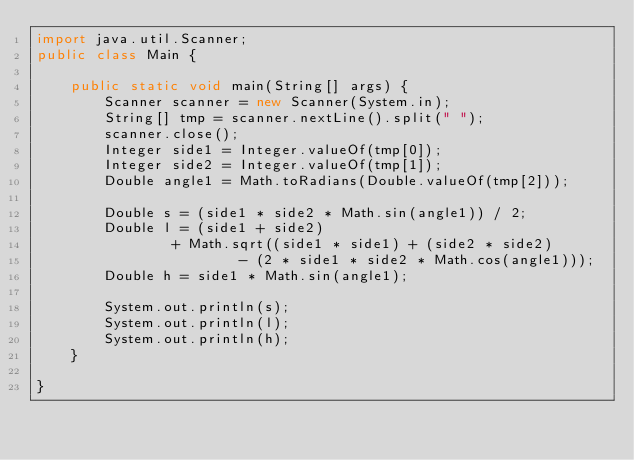Convert code to text. <code><loc_0><loc_0><loc_500><loc_500><_Java_>import java.util.Scanner;
public class Main {

    public static void main(String[] args) {
        Scanner scanner = new Scanner(System.in);
        String[] tmp = scanner.nextLine().split(" ");
        scanner.close();
        Integer side1 = Integer.valueOf(tmp[0]);
        Integer side2 = Integer.valueOf(tmp[1]);
        Double angle1 = Math.toRadians(Double.valueOf(tmp[2]));

        Double s = (side1 * side2 * Math.sin(angle1)) / 2;
        Double l = (side1 + side2)
                + Math.sqrt((side1 * side1) + (side2 * side2)
                        - (2 * side1 * side2 * Math.cos(angle1)));
        Double h = side1 * Math.sin(angle1);

        System.out.println(s);
        System.out.println(l);
        System.out.println(h);
    }

}</code> 